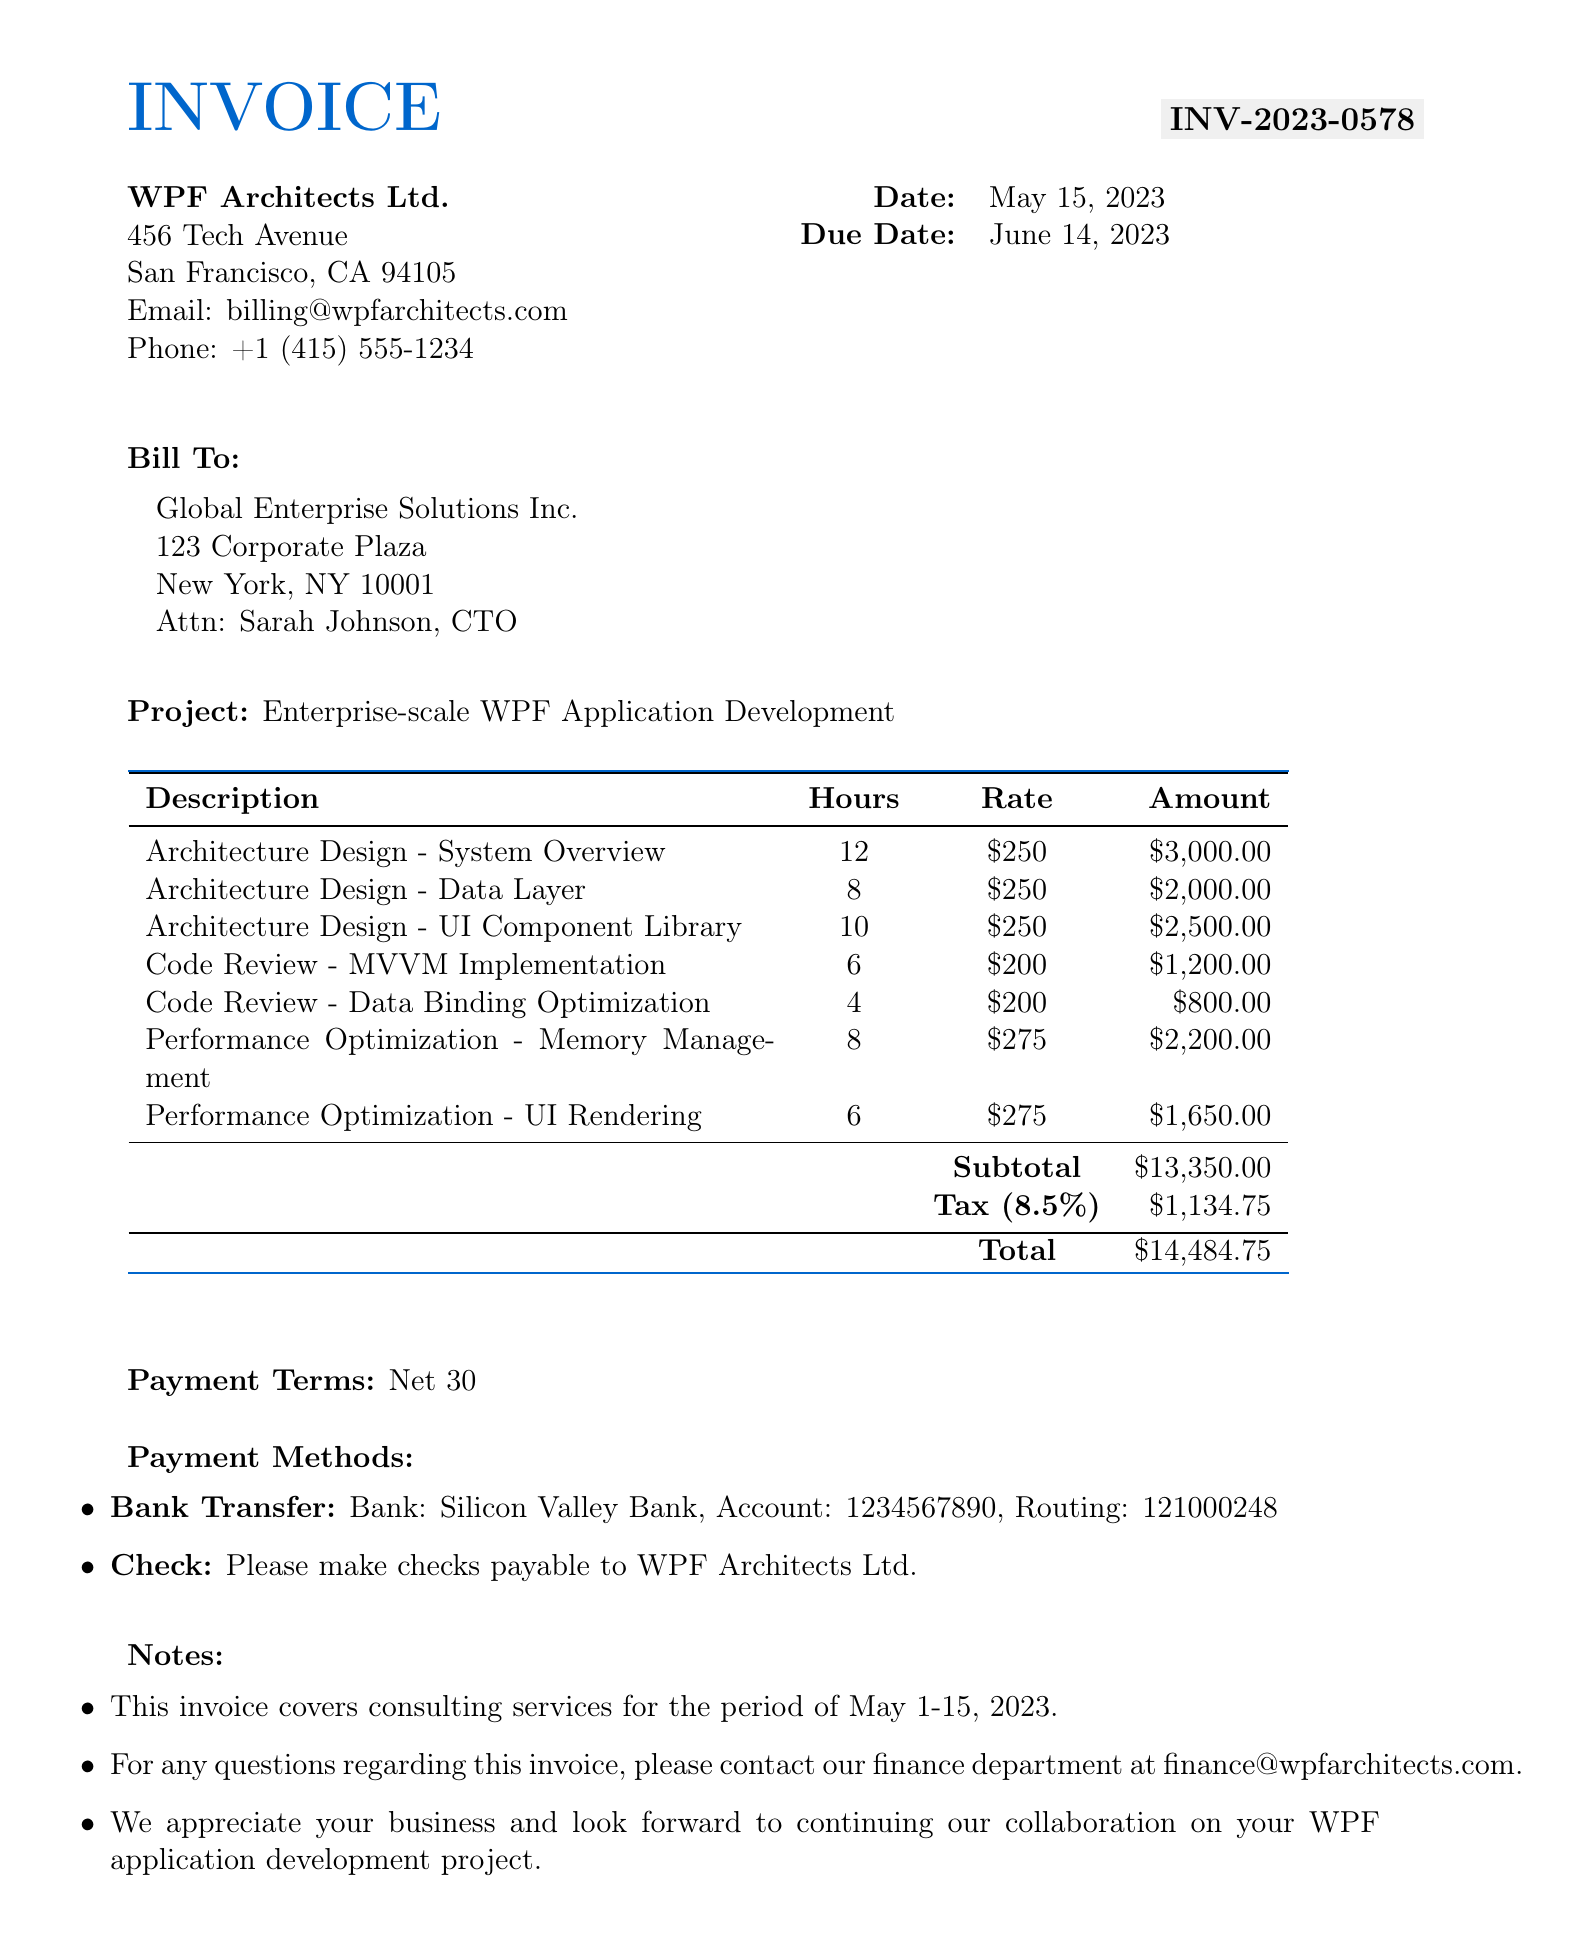What is the invoice number? The invoice number is found at the top of the document, which identifies the specific invoice for the services rendered.
Answer: INV-2023-0578 Who is the contact person for the client? The contact person is specified in the client section of the invoice, indicating who to reach for any inquiries.
Answer: Sarah Johnson, CTO What is the total amount due? The total amount due is calculated by adding the subtotal and tax amount, representing the final amount to be paid.
Answer: $14,484.75 How many hours were spent on Architecture Design - UI Component Library? The hours for each line item are listed in the table, detailing the time invested in various services.
Answer: 10 What is the tax rate applied to this invoice? The tax rate is provided in the financial summary section, which affects the total amount due.
Answer: 8.5% What was the main project for this invoice? The project name is mentioned below the billing information, describing the focus of the consultation efforts.
Answer: Enterprise-scale WPF Application Development What payment term is specified in this invoice? Payment terms are clearly outlined in the invoice, indicating when payment is expected after the due date.
Answer: Net 30 How much was charged for Code Review - MVVM Implementation? The amount is provided in the line item table, showing the cost associated with each specific service provided.
Answer: $1,200.00 What type of payment methods are accepted? Payment methods are listed in the document, providing options available for settling the invoice.
Answer: Bank Transfer, Check 